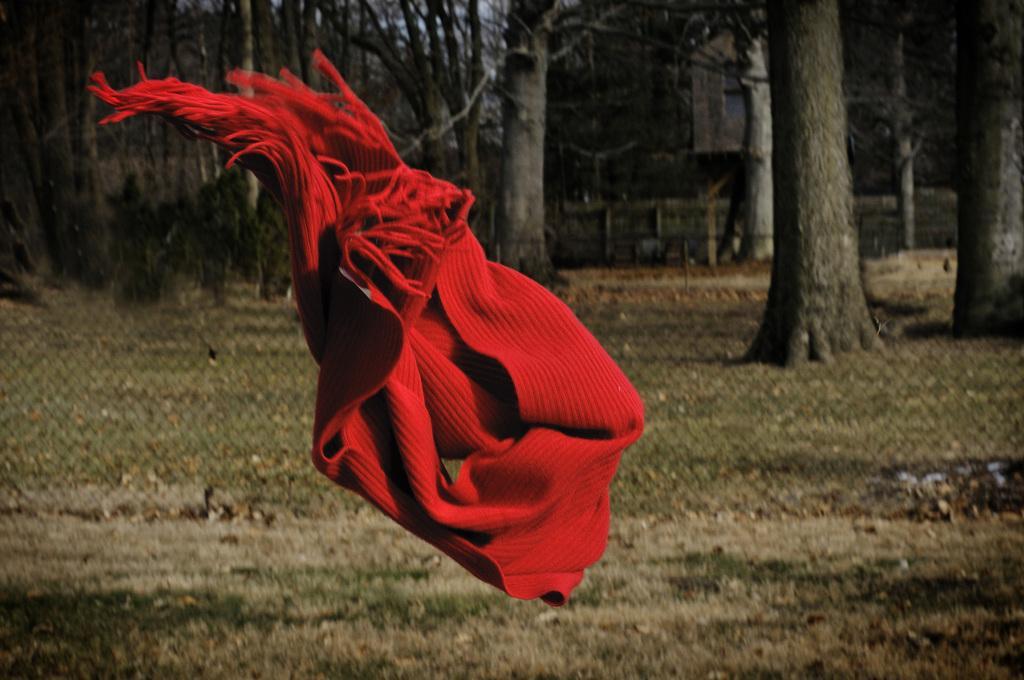In one or two sentences, can you explain what this image depicts? In this image a scarf is flying in air. Behind the scarf there is fence. There are few trees on the grassland. Behind it there is a building. 